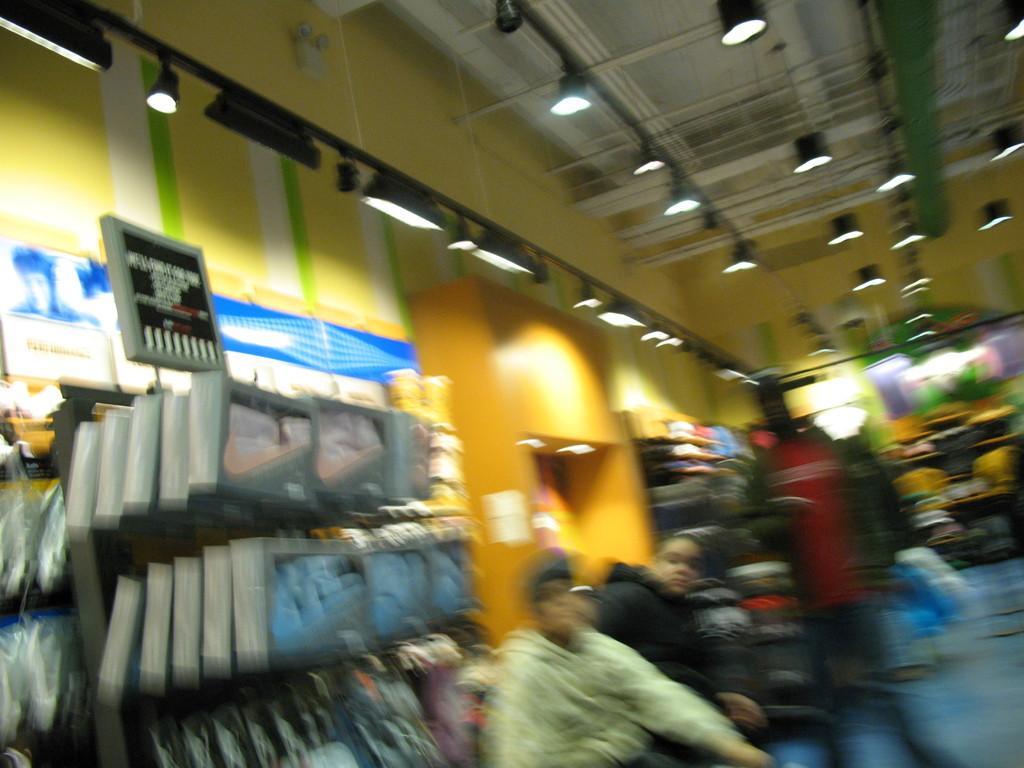Can you describe this image briefly? This is a blurred image. We can see people, boards, lights, wall and some objects. 